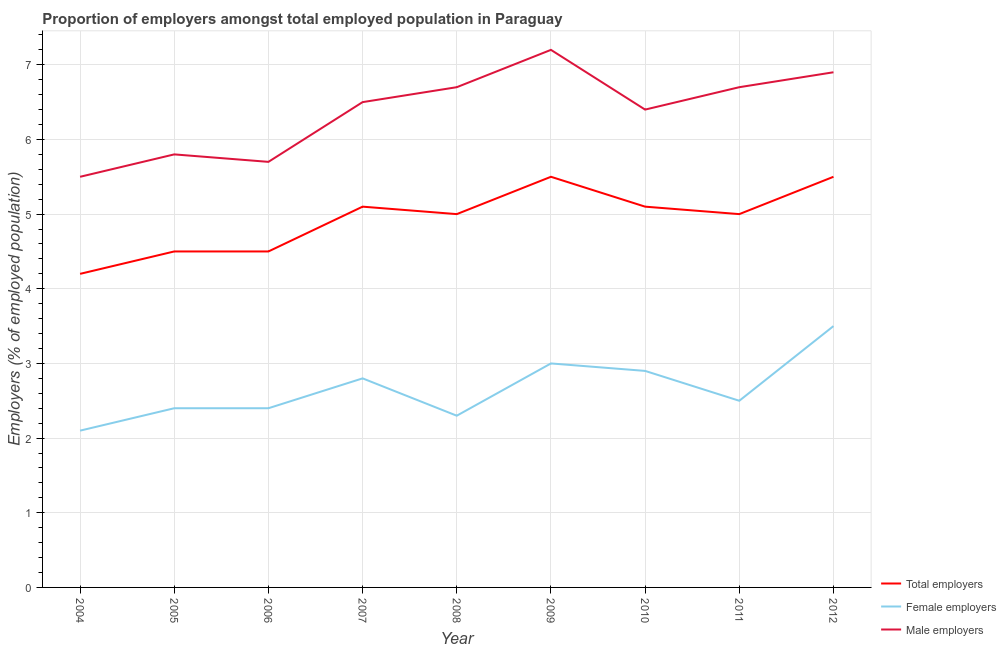Does the line corresponding to percentage of male employers intersect with the line corresponding to percentage of female employers?
Your answer should be compact. No. What is the percentage of male employers in 2011?
Keep it short and to the point. 6.7. Across all years, what is the minimum percentage of female employers?
Provide a succinct answer. 2.1. What is the total percentage of male employers in the graph?
Provide a short and direct response. 57.4. What is the difference between the percentage of male employers in 2004 and that in 2011?
Offer a terse response. -1.2. What is the difference between the percentage of total employers in 2010 and the percentage of female employers in 2009?
Offer a very short reply. 2.1. What is the average percentage of male employers per year?
Provide a succinct answer. 6.38. In the year 2008, what is the difference between the percentage of male employers and percentage of total employers?
Ensure brevity in your answer.  1.7. What is the ratio of the percentage of total employers in 2006 to that in 2007?
Your answer should be very brief. 0.88. Is the percentage of male employers in 2005 less than that in 2012?
Provide a succinct answer. Yes. What is the difference between the highest and the second highest percentage of male employers?
Keep it short and to the point. 0.3. What is the difference between the highest and the lowest percentage of female employers?
Provide a succinct answer. 1.4. Does the percentage of total employers monotonically increase over the years?
Make the answer very short. No. Is the percentage of female employers strictly greater than the percentage of total employers over the years?
Keep it short and to the point. No. Is the percentage of total employers strictly less than the percentage of female employers over the years?
Offer a very short reply. No. How many lines are there?
Keep it short and to the point. 3. How many years are there in the graph?
Provide a short and direct response. 9. What is the difference between two consecutive major ticks on the Y-axis?
Your answer should be very brief. 1. Are the values on the major ticks of Y-axis written in scientific E-notation?
Make the answer very short. No. Does the graph contain any zero values?
Ensure brevity in your answer.  No. How many legend labels are there?
Offer a terse response. 3. How are the legend labels stacked?
Keep it short and to the point. Vertical. What is the title of the graph?
Offer a very short reply. Proportion of employers amongst total employed population in Paraguay. What is the label or title of the X-axis?
Offer a very short reply. Year. What is the label or title of the Y-axis?
Your answer should be very brief. Employers (% of employed population). What is the Employers (% of employed population) in Total employers in 2004?
Your response must be concise. 4.2. What is the Employers (% of employed population) of Female employers in 2004?
Make the answer very short. 2.1. What is the Employers (% of employed population) in Total employers in 2005?
Offer a terse response. 4.5. What is the Employers (% of employed population) in Female employers in 2005?
Keep it short and to the point. 2.4. What is the Employers (% of employed population) in Male employers in 2005?
Provide a succinct answer. 5.8. What is the Employers (% of employed population) in Total employers in 2006?
Your answer should be very brief. 4.5. What is the Employers (% of employed population) in Female employers in 2006?
Your answer should be very brief. 2.4. What is the Employers (% of employed population) in Male employers in 2006?
Your answer should be very brief. 5.7. What is the Employers (% of employed population) in Total employers in 2007?
Keep it short and to the point. 5.1. What is the Employers (% of employed population) in Female employers in 2007?
Offer a terse response. 2.8. What is the Employers (% of employed population) of Female employers in 2008?
Offer a very short reply. 2.3. What is the Employers (% of employed population) in Male employers in 2008?
Provide a short and direct response. 6.7. What is the Employers (% of employed population) in Total employers in 2009?
Ensure brevity in your answer.  5.5. What is the Employers (% of employed population) in Male employers in 2009?
Your answer should be compact. 7.2. What is the Employers (% of employed population) in Total employers in 2010?
Provide a short and direct response. 5.1. What is the Employers (% of employed population) in Female employers in 2010?
Keep it short and to the point. 2.9. What is the Employers (% of employed population) of Male employers in 2010?
Give a very brief answer. 6.4. What is the Employers (% of employed population) in Total employers in 2011?
Keep it short and to the point. 5. What is the Employers (% of employed population) of Female employers in 2011?
Give a very brief answer. 2.5. What is the Employers (% of employed population) of Male employers in 2011?
Give a very brief answer. 6.7. What is the Employers (% of employed population) of Female employers in 2012?
Your answer should be compact. 3.5. What is the Employers (% of employed population) of Male employers in 2012?
Your response must be concise. 6.9. Across all years, what is the maximum Employers (% of employed population) of Total employers?
Provide a succinct answer. 5.5. Across all years, what is the maximum Employers (% of employed population) of Male employers?
Your response must be concise. 7.2. Across all years, what is the minimum Employers (% of employed population) in Total employers?
Your response must be concise. 4.2. Across all years, what is the minimum Employers (% of employed population) of Female employers?
Provide a short and direct response. 2.1. Across all years, what is the minimum Employers (% of employed population) of Male employers?
Offer a terse response. 5.5. What is the total Employers (% of employed population) in Total employers in the graph?
Offer a terse response. 44.4. What is the total Employers (% of employed population) in Female employers in the graph?
Offer a very short reply. 23.9. What is the total Employers (% of employed population) of Male employers in the graph?
Your answer should be compact. 57.4. What is the difference between the Employers (% of employed population) of Female employers in 2004 and that in 2005?
Make the answer very short. -0.3. What is the difference between the Employers (% of employed population) in Female employers in 2004 and that in 2007?
Ensure brevity in your answer.  -0.7. What is the difference between the Employers (% of employed population) of Male employers in 2004 and that in 2007?
Provide a succinct answer. -1. What is the difference between the Employers (% of employed population) of Female employers in 2004 and that in 2008?
Provide a short and direct response. -0.2. What is the difference between the Employers (% of employed population) of Male employers in 2004 and that in 2008?
Offer a terse response. -1.2. What is the difference between the Employers (% of employed population) of Female employers in 2004 and that in 2009?
Give a very brief answer. -0.9. What is the difference between the Employers (% of employed population) in Male employers in 2004 and that in 2009?
Offer a very short reply. -1.7. What is the difference between the Employers (% of employed population) in Female employers in 2004 and that in 2010?
Your answer should be very brief. -0.8. What is the difference between the Employers (% of employed population) of Male employers in 2004 and that in 2011?
Ensure brevity in your answer.  -1.2. What is the difference between the Employers (% of employed population) of Total employers in 2004 and that in 2012?
Give a very brief answer. -1.3. What is the difference between the Employers (% of employed population) in Female employers in 2004 and that in 2012?
Your answer should be compact. -1.4. What is the difference between the Employers (% of employed population) in Total employers in 2005 and that in 2006?
Provide a short and direct response. 0. What is the difference between the Employers (% of employed population) in Male employers in 2005 and that in 2006?
Your answer should be very brief. 0.1. What is the difference between the Employers (% of employed population) of Female employers in 2005 and that in 2007?
Ensure brevity in your answer.  -0.4. What is the difference between the Employers (% of employed population) of Male employers in 2005 and that in 2007?
Ensure brevity in your answer.  -0.7. What is the difference between the Employers (% of employed population) of Total employers in 2005 and that in 2008?
Provide a succinct answer. -0.5. What is the difference between the Employers (% of employed population) in Male employers in 2005 and that in 2008?
Keep it short and to the point. -0.9. What is the difference between the Employers (% of employed population) of Female employers in 2005 and that in 2009?
Give a very brief answer. -0.6. What is the difference between the Employers (% of employed population) in Female employers in 2005 and that in 2010?
Offer a very short reply. -0.5. What is the difference between the Employers (% of employed population) of Male employers in 2005 and that in 2010?
Provide a short and direct response. -0.6. What is the difference between the Employers (% of employed population) of Total employers in 2005 and that in 2011?
Make the answer very short. -0.5. What is the difference between the Employers (% of employed population) of Female employers in 2005 and that in 2012?
Provide a short and direct response. -1.1. What is the difference between the Employers (% of employed population) of Male employers in 2005 and that in 2012?
Your response must be concise. -1.1. What is the difference between the Employers (% of employed population) in Total employers in 2006 and that in 2007?
Your answer should be very brief. -0.6. What is the difference between the Employers (% of employed population) of Male employers in 2006 and that in 2008?
Your answer should be compact. -1. What is the difference between the Employers (% of employed population) in Total employers in 2006 and that in 2009?
Provide a short and direct response. -1. What is the difference between the Employers (% of employed population) in Female employers in 2006 and that in 2009?
Give a very brief answer. -0.6. What is the difference between the Employers (% of employed population) of Male employers in 2006 and that in 2009?
Keep it short and to the point. -1.5. What is the difference between the Employers (% of employed population) of Total employers in 2006 and that in 2011?
Ensure brevity in your answer.  -0.5. What is the difference between the Employers (% of employed population) in Male employers in 2006 and that in 2011?
Offer a very short reply. -1. What is the difference between the Employers (% of employed population) in Total employers in 2006 and that in 2012?
Give a very brief answer. -1. What is the difference between the Employers (% of employed population) in Total employers in 2007 and that in 2008?
Make the answer very short. 0.1. What is the difference between the Employers (% of employed population) of Female employers in 2007 and that in 2008?
Offer a terse response. 0.5. What is the difference between the Employers (% of employed population) of Male employers in 2007 and that in 2009?
Ensure brevity in your answer.  -0.7. What is the difference between the Employers (% of employed population) of Total employers in 2007 and that in 2010?
Provide a succinct answer. 0. What is the difference between the Employers (% of employed population) of Total employers in 2007 and that in 2011?
Provide a succinct answer. 0.1. What is the difference between the Employers (% of employed population) of Male employers in 2007 and that in 2011?
Your answer should be compact. -0.2. What is the difference between the Employers (% of employed population) of Total employers in 2007 and that in 2012?
Ensure brevity in your answer.  -0.4. What is the difference between the Employers (% of employed population) of Female employers in 2008 and that in 2009?
Ensure brevity in your answer.  -0.7. What is the difference between the Employers (% of employed population) in Male employers in 2008 and that in 2009?
Provide a succinct answer. -0.5. What is the difference between the Employers (% of employed population) in Male employers in 2008 and that in 2010?
Provide a short and direct response. 0.3. What is the difference between the Employers (% of employed population) in Female employers in 2008 and that in 2011?
Provide a short and direct response. -0.2. What is the difference between the Employers (% of employed population) in Male employers in 2009 and that in 2010?
Provide a succinct answer. 0.8. What is the difference between the Employers (% of employed population) of Total employers in 2009 and that in 2012?
Your answer should be compact. 0. What is the difference between the Employers (% of employed population) in Female employers in 2009 and that in 2012?
Keep it short and to the point. -0.5. What is the difference between the Employers (% of employed population) of Total employers in 2010 and that in 2011?
Give a very brief answer. 0.1. What is the difference between the Employers (% of employed population) of Female employers in 2010 and that in 2012?
Your answer should be compact. -0.6. What is the difference between the Employers (% of employed population) of Male employers in 2010 and that in 2012?
Your answer should be compact. -0.5. What is the difference between the Employers (% of employed population) in Total employers in 2011 and that in 2012?
Ensure brevity in your answer.  -0.5. What is the difference between the Employers (% of employed population) in Male employers in 2011 and that in 2012?
Give a very brief answer. -0.2. What is the difference between the Employers (% of employed population) in Total employers in 2004 and the Employers (% of employed population) in Female employers in 2005?
Offer a terse response. 1.8. What is the difference between the Employers (% of employed population) in Total employers in 2004 and the Employers (% of employed population) in Male employers in 2005?
Offer a very short reply. -1.6. What is the difference between the Employers (% of employed population) of Female employers in 2004 and the Employers (% of employed population) of Male employers in 2005?
Your response must be concise. -3.7. What is the difference between the Employers (% of employed population) of Total employers in 2004 and the Employers (% of employed population) of Female employers in 2007?
Your response must be concise. 1.4. What is the difference between the Employers (% of employed population) of Total employers in 2004 and the Employers (% of employed population) of Male employers in 2007?
Provide a succinct answer. -2.3. What is the difference between the Employers (% of employed population) of Female employers in 2004 and the Employers (% of employed population) of Male employers in 2007?
Your response must be concise. -4.4. What is the difference between the Employers (% of employed population) in Total employers in 2004 and the Employers (% of employed population) in Female employers in 2009?
Make the answer very short. 1.2. What is the difference between the Employers (% of employed population) of Female employers in 2004 and the Employers (% of employed population) of Male employers in 2009?
Give a very brief answer. -5.1. What is the difference between the Employers (% of employed population) of Total employers in 2004 and the Employers (% of employed population) of Female employers in 2010?
Offer a very short reply. 1.3. What is the difference between the Employers (% of employed population) of Total employers in 2004 and the Employers (% of employed population) of Female employers in 2012?
Your answer should be very brief. 0.7. What is the difference between the Employers (% of employed population) of Total employers in 2005 and the Employers (% of employed population) of Male employers in 2006?
Provide a short and direct response. -1.2. What is the difference between the Employers (% of employed population) in Female employers in 2005 and the Employers (% of employed population) in Male employers in 2006?
Give a very brief answer. -3.3. What is the difference between the Employers (% of employed population) in Total employers in 2005 and the Employers (% of employed population) in Male employers in 2007?
Provide a short and direct response. -2. What is the difference between the Employers (% of employed population) of Total employers in 2005 and the Employers (% of employed population) of Female employers in 2008?
Your answer should be compact. 2.2. What is the difference between the Employers (% of employed population) of Total employers in 2005 and the Employers (% of employed population) of Male employers in 2008?
Ensure brevity in your answer.  -2.2. What is the difference between the Employers (% of employed population) in Female employers in 2005 and the Employers (% of employed population) in Male employers in 2008?
Offer a terse response. -4.3. What is the difference between the Employers (% of employed population) in Total employers in 2005 and the Employers (% of employed population) in Female employers in 2010?
Your answer should be compact. 1.6. What is the difference between the Employers (% of employed population) of Total employers in 2005 and the Employers (% of employed population) of Male employers in 2010?
Your response must be concise. -1.9. What is the difference between the Employers (% of employed population) in Female employers in 2005 and the Employers (% of employed population) in Male employers in 2010?
Give a very brief answer. -4. What is the difference between the Employers (% of employed population) of Total employers in 2005 and the Employers (% of employed population) of Male employers in 2011?
Ensure brevity in your answer.  -2.2. What is the difference between the Employers (% of employed population) of Total employers in 2005 and the Employers (% of employed population) of Female employers in 2012?
Offer a terse response. 1. What is the difference between the Employers (% of employed population) of Total employers in 2006 and the Employers (% of employed population) of Female employers in 2007?
Offer a terse response. 1.7. What is the difference between the Employers (% of employed population) of Total employers in 2006 and the Employers (% of employed population) of Male employers in 2007?
Your answer should be very brief. -2. What is the difference between the Employers (% of employed population) of Female employers in 2006 and the Employers (% of employed population) of Male employers in 2007?
Offer a very short reply. -4.1. What is the difference between the Employers (% of employed population) in Female employers in 2006 and the Employers (% of employed population) in Male employers in 2008?
Your answer should be very brief. -4.3. What is the difference between the Employers (% of employed population) of Total employers in 2006 and the Employers (% of employed population) of Male employers in 2009?
Make the answer very short. -2.7. What is the difference between the Employers (% of employed population) of Female employers in 2006 and the Employers (% of employed population) of Male employers in 2010?
Provide a succinct answer. -4. What is the difference between the Employers (% of employed population) in Total employers in 2006 and the Employers (% of employed population) in Female employers in 2012?
Keep it short and to the point. 1. What is the difference between the Employers (% of employed population) in Total employers in 2006 and the Employers (% of employed population) in Male employers in 2012?
Ensure brevity in your answer.  -2.4. What is the difference between the Employers (% of employed population) of Female employers in 2006 and the Employers (% of employed population) of Male employers in 2012?
Offer a very short reply. -4.5. What is the difference between the Employers (% of employed population) in Total employers in 2007 and the Employers (% of employed population) in Male employers in 2011?
Provide a short and direct response. -1.6. What is the difference between the Employers (% of employed population) in Female employers in 2007 and the Employers (% of employed population) in Male employers in 2011?
Your response must be concise. -3.9. What is the difference between the Employers (% of employed population) in Total employers in 2007 and the Employers (% of employed population) in Female employers in 2012?
Give a very brief answer. 1.6. What is the difference between the Employers (% of employed population) in Total employers in 2007 and the Employers (% of employed population) in Male employers in 2012?
Your answer should be very brief. -1.8. What is the difference between the Employers (% of employed population) in Female employers in 2007 and the Employers (% of employed population) in Male employers in 2012?
Offer a very short reply. -4.1. What is the difference between the Employers (% of employed population) in Female employers in 2008 and the Employers (% of employed population) in Male employers in 2009?
Your answer should be compact. -4.9. What is the difference between the Employers (% of employed population) in Total employers in 2008 and the Employers (% of employed population) in Female employers in 2010?
Your answer should be compact. 2.1. What is the difference between the Employers (% of employed population) in Total employers in 2008 and the Employers (% of employed population) in Male employers in 2010?
Your answer should be very brief. -1.4. What is the difference between the Employers (% of employed population) of Total employers in 2009 and the Employers (% of employed population) of Female employers in 2010?
Your response must be concise. 2.6. What is the difference between the Employers (% of employed population) of Total employers in 2009 and the Employers (% of employed population) of Male employers in 2010?
Provide a short and direct response. -0.9. What is the difference between the Employers (% of employed population) of Female employers in 2009 and the Employers (% of employed population) of Male employers in 2010?
Your answer should be very brief. -3.4. What is the difference between the Employers (% of employed population) of Total employers in 2009 and the Employers (% of employed population) of Male employers in 2011?
Give a very brief answer. -1.2. What is the difference between the Employers (% of employed population) of Female employers in 2009 and the Employers (% of employed population) of Male employers in 2011?
Keep it short and to the point. -3.7. What is the difference between the Employers (% of employed population) of Female employers in 2009 and the Employers (% of employed population) of Male employers in 2012?
Offer a very short reply. -3.9. What is the difference between the Employers (% of employed population) in Female employers in 2010 and the Employers (% of employed population) in Male employers in 2011?
Your answer should be very brief. -3.8. What is the difference between the Employers (% of employed population) in Total employers in 2010 and the Employers (% of employed population) in Female employers in 2012?
Ensure brevity in your answer.  1.6. What is the difference between the Employers (% of employed population) of Total employers in 2010 and the Employers (% of employed population) of Male employers in 2012?
Your answer should be compact. -1.8. What is the difference between the Employers (% of employed population) of Female employers in 2010 and the Employers (% of employed population) of Male employers in 2012?
Make the answer very short. -4. What is the difference between the Employers (% of employed population) in Total employers in 2011 and the Employers (% of employed population) in Female employers in 2012?
Your answer should be very brief. 1.5. What is the difference between the Employers (% of employed population) in Female employers in 2011 and the Employers (% of employed population) in Male employers in 2012?
Your response must be concise. -4.4. What is the average Employers (% of employed population) of Total employers per year?
Ensure brevity in your answer.  4.93. What is the average Employers (% of employed population) in Female employers per year?
Keep it short and to the point. 2.66. What is the average Employers (% of employed population) in Male employers per year?
Your answer should be very brief. 6.38. In the year 2004, what is the difference between the Employers (% of employed population) of Total employers and Employers (% of employed population) of Female employers?
Offer a terse response. 2.1. In the year 2004, what is the difference between the Employers (% of employed population) in Total employers and Employers (% of employed population) in Male employers?
Provide a short and direct response. -1.3. In the year 2004, what is the difference between the Employers (% of employed population) of Female employers and Employers (% of employed population) of Male employers?
Your answer should be very brief. -3.4. In the year 2005, what is the difference between the Employers (% of employed population) of Total employers and Employers (% of employed population) of Female employers?
Offer a very short reply. 2.1. In the year 2006, what is the difference between the Employers (% of employed population) in Total employers and Employers (% of employed population) in Female employers?
Provide a succinct answer. 2.1. In the year 2006, what is the difference between the Employers (% of employed population) in Total employers and Employers (% of employed population) in Male employers?
Your response must be concise. -1.2. In the year 2007, what is the difference between the Employers (% of employed population) of Total employers and Employers (% of employed population) of Female employers?
Provide a short and direct response. 2.3. In the year 2007, what is the difference between the Employers (% of employed population) of Total employers and Employers (% of employed population) of Male employers?
Make the answer very short. -1.4. In the year 2008, what is the difference between the Employers (% of employed population) in Total employers and Employers (% of employed population) in Male employers?
Your response must be concise. -1.7. In the year 2008, what is the difference between the Employers (% of employed population) of Female employers and Employers (% of employed population) of Male employers?
Provide a succinct answer. -4.4. In the year 2009, what is the difference between the Employers (% of employed population) in Total employers and Employers (% of employed population) in Female employers?
Keep it short and to the point. 2.5. In the year 2009, what is the difference between the Employers (% of employed population) in Female employers and Employers (% of employed population) in Male employers?
Provide a short and direct response. -4.2. In the year 2010, what is the difference between the Employers (% of employed population) in Total employers and Employers (% of employed population) in Male employers?
Ensure brevity in your answer.  -1.3. In the year 2011, what is the difference between the Employers (% of employed population) in Total employers and Employers (% of employed population) in Female employers?
Your answer should be compact. 2.5. In the year 2011, what is the difference between the Employers (% of employed population) of Total employers and Employers (% of employed population) of Male employers?
Provide a succinct answer. -1.7. In the year 2011, what is the difference between the Employers (% of employed population) in Female employers and Employers (% of employed population) in Male employers?
Provide a short and direct response. -4.2. In the year 2012, what is the difference between the Employers (% of employed population) of Total employers and Employers (% of employed population) of Male employers?
Offer a terse response. -1.4. In the year 2012, what is the difference between the Employers (% of employed population) of Female employers and Employers (% of employed population) of Male employers?
Provide a short and direct response. -3.4. What is the ratio of the Employers (% of employed population) of Total employers in 2004 to that in 2005?
Ensure brevity in your answer.  0.93. What is the ratio of the Employers (% of employed population) in Female employers in 2004 to that in 2005?
Your response must be concise. 0.88. What is the ratio of the Employers (% of employed population) in Male employers in 2004 to that in 2005?
Offer a terse response. 0.95. What is the ratio of the Employers (% of employed population) in Female employers in 2004 to that in 2006?
Offer a very short reply. 0.88. What is the ratio of the Employers (% of employed population) of Male employers in 2004 to that in 2006?
Your answer should be very brief. 0.96. What is the ratio of the Employers (% of employed population) of Total employers in 2004 to that in 2007?
Provide a succinct answer. 0.82. What is the ratio of the Employers (% of employed population) in Male employers in 2004 to that in 2007?
Your answer should be compact. 0.85. What is the ratio of the Employers (% of employed population) of Total employers in 2004 to that in 2008?
Ensure brevity in your answer.  0.84. What is the ratio of the Employers (% of employed population) of Male employers in 2004 to that in 2008?
Provide a short and direct response. 0.82. What is the ratio of the Employers (% of employed population) of Total employers in 2004 to that in 2009?
Provide a succinct answer. 0.76. What is the ratio of the Employers (% of employed population) in Female employers in 2004 to that in 2009?
Provide a succinct answer. 0.7. What is the ratio of the Employers (% of employed population) in Male employers in 2004 to that in 2009?
Your response must be concise. 0.76. What is the ratio of the Employers (% of employed population) in Total employers in 2004 to that in 2010?
Give a very brief answer. 0.82. What is the ratio of the Employers (% of employed population) of Female employers in 2004 to that in 2010?
Your response must be concise. 0.72. What is the ratio of the Employers (% of employed population) of Male employers in 2004 to that in 2010?
Ensure brevity in your answer.  0.86. What is the ratio of the Employers (% of employed population) in Total employers in 2004 to that in 2011?
Your response must be concise. 0.84. What is the ratio of the Employers (% of employed population) in Female employers in 2004 to that in 2011?
Offer a terse response. 0.84. What is the ratio of the Employers (% of employed population) in Male employers in 2004 to that in 2011?
Offer a terse response. 0.82. What is the ratio of the Employers (% of employed population) in Total employers in 2004 to that in 2012?
Offer a very short reply. 0.76. What is the ratio of the Employers (% of employed population) in Male employers in 2004 to that in 2012?
Offer a very short reply. 0.8. What is the ratio of the Employers (% of employed population) of Total employers in 2005 to that in 2006?
Your answer should be compact. 1. What is the ratio of the Employers (% of employed population) in Female employers in 2005 to that in 2006?
Offer a terse response. 1. What is the ratio of the Employers (% of employed population) of Male employers in 2005 to that in 2006?
Give a very brief answer. 1.02. What is the ratio of the Employers (% of employed population) of Total employers in 2005 to that in 2007?
Offer a terse response. 0.88. What is the ratio of the Employers (% of employed population) of Female employers in 2005 to that in 2007?
Provide a succinct answer. 0.86. What is the ratio of the Employers (% of employed population) in Male employers in 2005 to that in 2007?
Offer a very short reply. 0.89. What is the ratio of the Employers (% of employed population) of Total employers in 2005 to that in 2008?
Ensure brevity in your answer.  0.9. What is the ratio of the Employers (% of employed population) of Female employers in 2005 to that in 2008?
Make the answer very short. 1.04. What is the ratio of the Employers (% of employed population) of Male employers in 2005 to that in 2008?
Your response must be concise. 0.87. What is the ratio of the Employers (% of employed population) of Total employers in 2005 to that in 2009?
Ensure brevity in your answer.  0.82. What is the ratio of the Employers (% of employed population) of Male employers in 2005 to that in 2009?
Make the answer very short. 0.81. What is the ratio of the Employers (% of employed population) in Total employers in 2005 to that in 2010?
Ensure brevity in your answer.  0.88. What is the ratio of the Employers (% of employed population) of Female employers in 2005 to that in 2010?
Keep it short and to the point. 0.83. What is the ratio of the Employers (% of employed population) of Male employers in 2005 to that in 2010?
Keep it short and to the point. 0.91. What is the ratio of the Employers (% of employed population) of Total employers in 2005 to that in 2011?
Your answer should be compact. 0.9. What is the ratio of the Employers (% of employed population) of Male employers in 2005 to that in 2011?
Offer a very short reply. 0.87. What is the ratio of the Employers (% of employed population) in Total employers in 2005 to that in 2012?
Your answer should be very brief. 0.82. What is the ratio of the Employers (% of employed population) in Female employers in 2005 to that in 2012?
Make the answer very short. 0.69. What is the ratio of the Employers (% of employed population) in Male employers in 2005 to that in 2012?
Offer a very short reply. 0.84. What is the ratio of the Employers (% of employed population) of Total employers in 2006 to that in 2007?
Give a very brief answer. 0.88. What is the ratio of the Employers (% of employed population) in Male employers in 2006 to that in 2007?
Provide a succinct answer. 0.88. What is the ratio of the Employers (% of employed population) of Female employers in 2006 to that in 2008?
Provide a short and direct response. 1.04. What is the ratio of the Employers (% of employed population) in Male employers in 2006 to that in 2008?
Ensure brevity in your answer.  0.85. What is the ratio of the Employers (% of employed population) in Total employers in 2006 to that in 2009?
Your answer should be compact. 0.82. What is the ratio of the Employers (% of employed population) of Male employers in 2006 to that in 2009?
Your answer should be very brief. 0.79. What is the ratio of the Employers (% of employed population) in Total employers in 2006 to that in 2010?
Offer a very short reply. 0.88. What is the ratio of the Employers (% of employed population) in Female employers in 2006 to that in 2010?
Keep it short and to the point. 0.83. What is the ratio of the Employers (% of employed population) of Male employers in 2006 to that in 2010?
Provide a succinct answer. 0.89. What is the ratio of the Employers (% of employed population) of Female employers in 2006 to that in 2011?
Ensure brevity in your answer.  0.96. What is the ratio of the Employers (% of employed population) in Male employers in 2006 to that in 2011?
Your answer should be very brief. 0.85. What is the ratio of the Employers (% of employed population) of Total employers in 2006 to that in 2012?
Make the answer very short. 0.82. What is the ratio of the Employers (% of employed population) of Female employers in 2006 to that in 2012?
Keep it short and to the point. 0.69. What is the ratio of the Employers (% of employed population) in Male employers in 2006 to that in 2012?
Give a very brief answer. 0.83. What is the ratio of the Employers (% of employed population) of Total employers in 2007 to that in 2008?
Ensure brevity in your answer.  1.02. What is the ratio of the Employers (% of employed population) of Female employers in 2007 to that in 2008?
Ensure brevity in your answer.  1.22. What is the ratio of the Employers (% of employed population) of Male employers in 2007 to that in 2008?
Keep it short and to the point. 0.97. What is the ratio of the Employers (% of employed population) in Total employers in 2007 to that in 2009?
Give a very brief answer. 0.93. What is the ratio of the Employers (% of employed population) of Female employers in 2007 to that in 2009?
Make the answer very short. 0.93. What is the ratio of the Employers (% of employed population) of Male employers in 2007 to that in 2009?
Your response must be concise. 0.9. What is the ratio of the Employers (% of employed population) of Female employers in 2007 to that in 2010?
Offer a terse response. 0.97. What is the ratio of the Employers (% of employed population) of Male employers in 2007 to that in 2010?
Your answer should be very brief. 1.02. What is the ratio of the Employers (% of employed population) of Female employers in 2007 to that in 2011?
Your answer should be compact. 1.12. What is the ratio of the Employers (% of employed population) in Male employers in 2007 to that in 2011?
Provide a short and direct response. 0.97. What is the ratio of the Employers (% of employed population) of Total employers in 2007 to that in 2012?
Provide a succinct answer. 0.93. What is the ratio of the Employers (% of employed population) of Female employers in 2007 to that in 2012?
Keep it short and to the point. 0.8. What is the ratio of the Employers (% of employed population) in Male employers in 2007 to that in 2012?
Your answer should be very brief. 0.94. What is the ratio of the Employers (% of employed population) in Female employers in 2008 to that in 2009?
Ensure brevity in your answer.  0.77. What is the ratio of the Employers (% of employed population) in Male employers in 2008 to that in 2009?
Ensure brevity in your answer.  0.93. What is the ratio of the Employers (% of employed population) of Total employers in 2008 to that in 2010?
Keep it short and to the point. 0.98. What is the ratio of the Employers (% of employed population) in Female employers in 2008 to that in 2010?
Make the answer very short. 0.79. What is the ratio of the Employers (% of employed population) in Male employers in 2008 to that in 2010?
Provide a short and direct response. 1.05. What is the ratio of the Employers (% of employed population) of Female employers in 2008 to that in 2012?
Offer a terse response. 0.66. What is the ratio of the Employers (% of employed population) in Male employers in 2008 to that in 2012?
Make the answer very short. 0.97. What is the ratio of the Employers (% of employed population) of Total employers in 2009 to that in 2010?
Ensure brevity in your answer.  1.08. What is the ratio of the Employers (% of employed population) of Female employers in 2009 to that in 2010?
Keep it short and to the point. 1.03. What is the ratio of the Employers (% of employed population) of Male employers in 2009 to that in 2010?
Make the answer very short. 1.12. What is the ratio of the Employers (% of employed population) of Total employers in 2009 to that in 2011?
Provide a short and direct response. 1.1. What is the ratio of the Employers (% of employed population) of Male employers in 2009 to that in 2011?
Your response must be concise. 1.07. What is the ratio of the Employers (% of employed population) of Total employers in 2009 to that in 2012?
Ensure brevity in your answer.  1. What is the ratio of the Employers (% of employed population) in Male employers in 2009 to that in 2012?
Your answer should be very brief. 1.04. What is the ratio of the Employers (% of employed population) in Total employers in 2010 to that in 2011?
Provide a succinct answer. 1.02. What is the ratio of the Employers (% of employed population) of Female employers in 2010 to that in 2011?
Your answer should be very brief. 1.16. What is the ratio of the Employers (% of employed population) of Male employers in 2010 to that in 2011?
Ensure brevity in your answer.  0.96. What is the ratio of the Employers (% of employed population) in Total employers in 2010 to that in 2012?
Offer a very short reply. 0.93. What is the ratio of the Employers (% of employed population) in Female employers in 2010 to that in 2012?
Give a very brief answer. 0.83. What is the ratio of the Employers (% of employed population) in Male employers in 2010 to that in 2012?
Provide a succinct answer. 0.93. What is the ratio of the Employers (% of employed population) of Total employers in 2011 to that in 2012?
Give a very brief answer. 0.91. What is the difference between the highest and the second highest Employers (% of employed population) of Total employers?
Offer a very short reply. 0. What is the difference between the highest and the second highest Employers (% of employed population) of Female employers?
Offer a very short reply. 0.5. What is the difference between the highest and the second highest Employers (% of employed population) of Male employers?
Make the answer very short. 0.3. What is the difference between the highest and the lowest Employers (% of employed population) in Male employers?
Offer a very short reply. 1.7. 